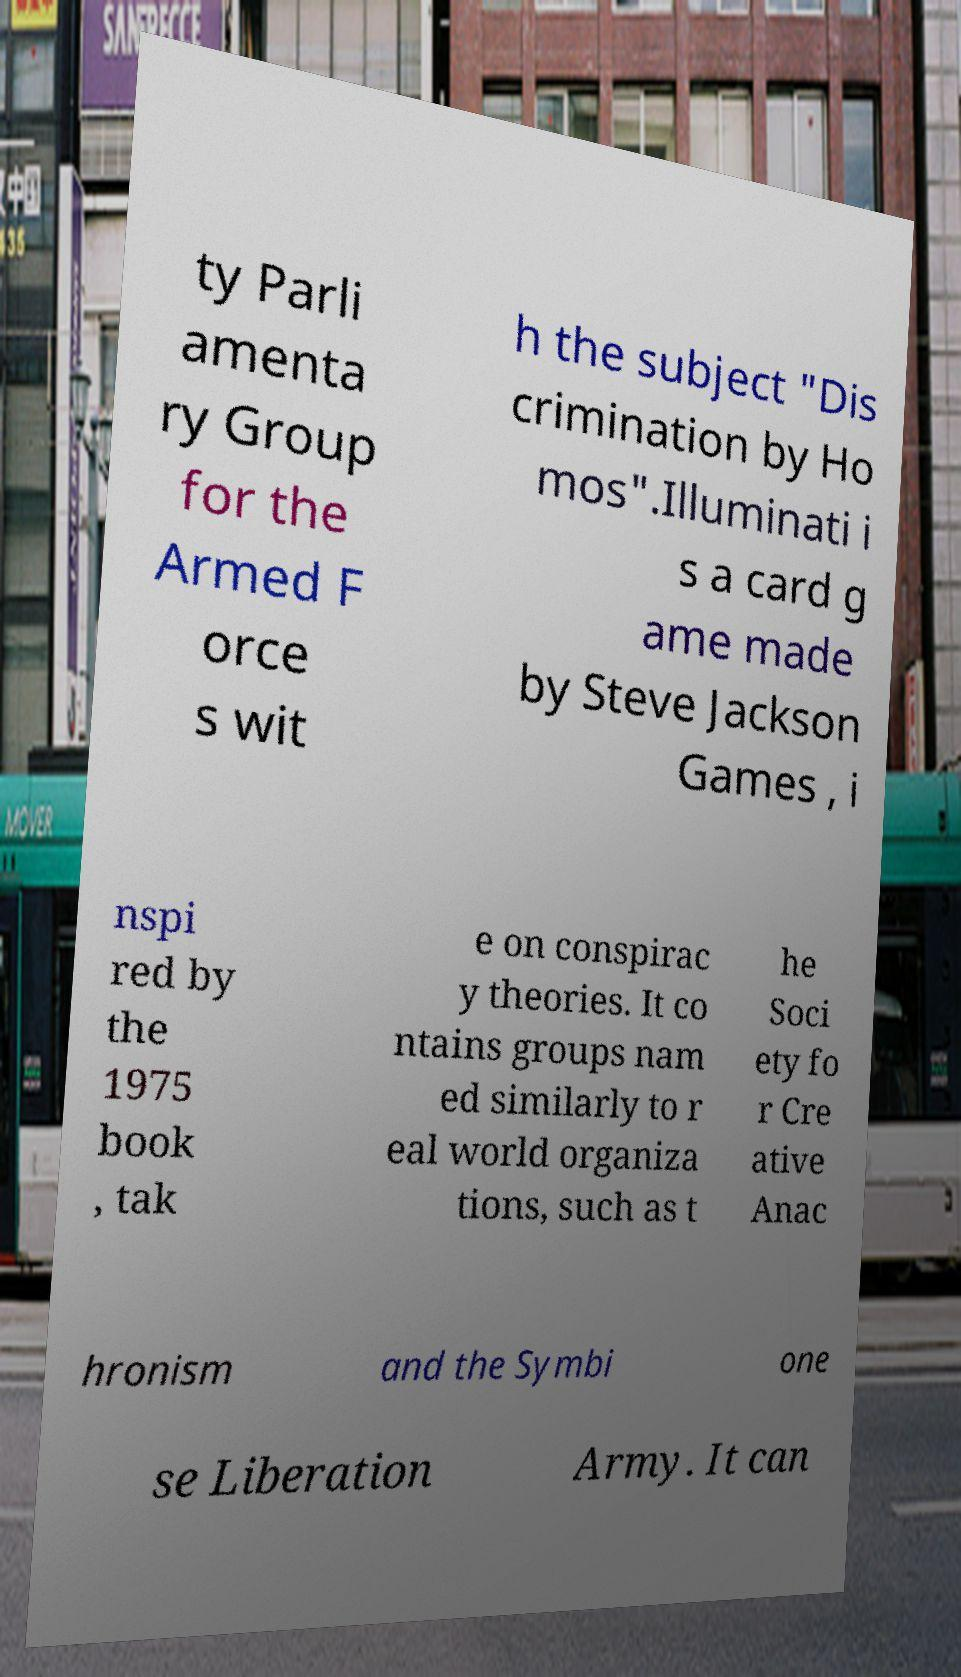Please read and relay the text visible in this image. What does it say? ty Parli amenta ry Group for the Armed F orce s wit h the subject "Dis crimination by Ho mos".Illuminati i s a card g ame made by Steve Jackson Games , i nspi red by the 1975 book , tak e on conspirac y theories. It co ntains groups nam ed similarly to r eal world organiza tions, such as t he Soci ety fo r Cre ative Anac hronism and the Symbi one se Liberation Army. It can 